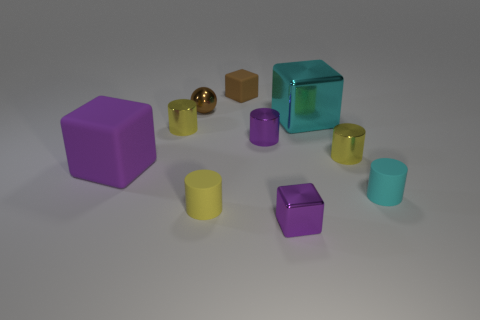What number of things are either metal things that are behind the small yellow matte cylinder or small things in front of the large cyan shiny object?
Your answer should be very brief. 8. What is the shape of the tiny purple metallic thing in front of the metallic thing right of the large metal thing?
Your answer should be compact. Cube. Is there anything else that is the same color as the tiny shiny ball?
Your answer should be compact. Yes. How many objects are gray matte objects or tiny objects?
Your answer should be compact. 8. Are there any purple rubber blocks that have the same size as the yellow rubber object?
Your response must be concise. No. The brown rubber thing is what shape?
Offer a very short reply. Cube. Is the number of big cyan shiny objects behind the large cyan shiny block greater than the number of brown rubber things that are on the left side of the small yellow matte thing?
Provide a succinct answer. No. There is a tiny rubber thing in front of the cyan cylinder; does it have the same color as the large cube left of the purple shiny cube?
Make the answer very short. No. There is a yellow rubber object that is the same size as the brown matte cube; what is its shape?
Make the answer very short. Cylinder. Are there any big cyan things that have the same shape as the purple rubber object?
Your response must be concise. Yes. 